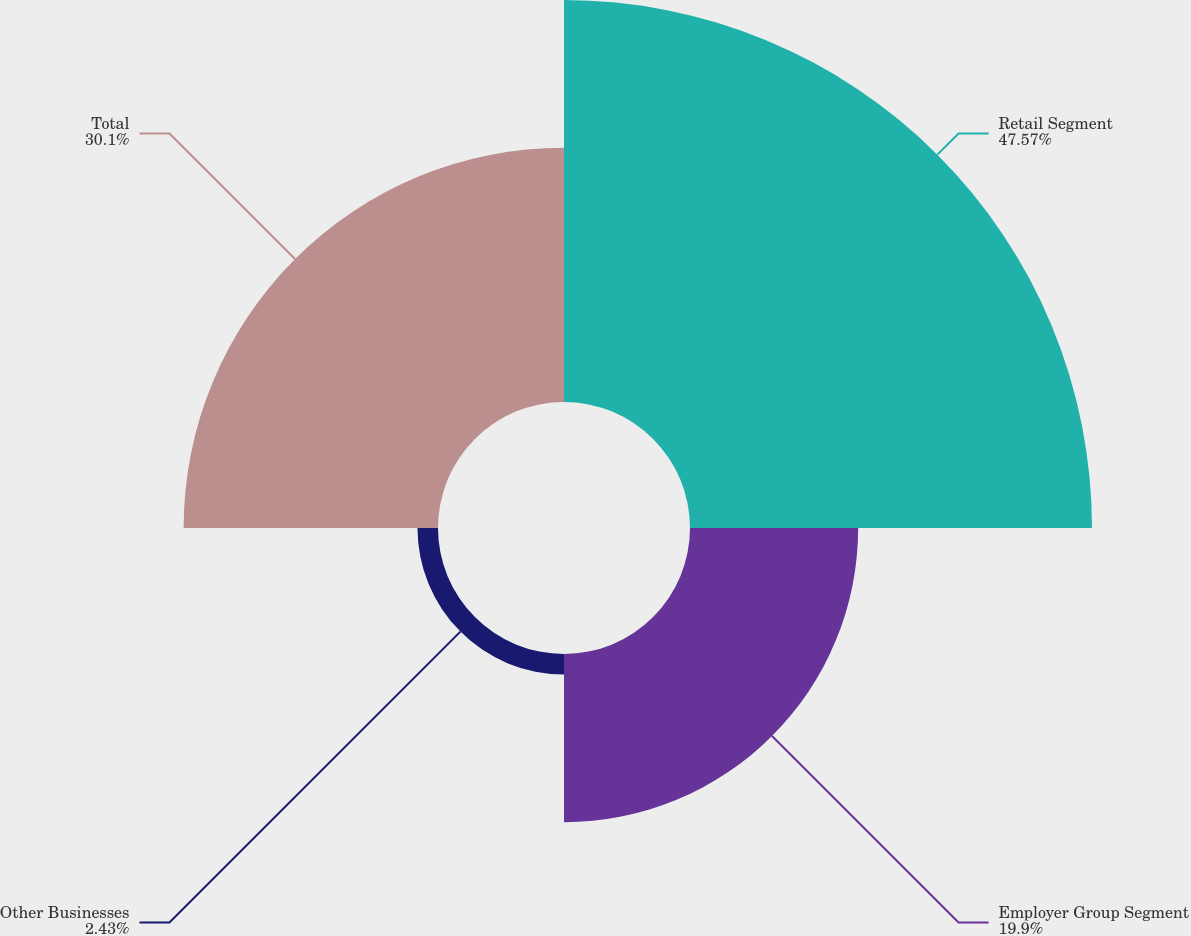Convert chart. <chart><loc_0><loc_0><loc_500><loc_500><pie_chart><fcel>Retail Segment<fcel>Employer Group Segment<fcel>Other Businesses<fcel>Total<nl><fcel>47.57%<fcel>19.9%<fcel>2.43%<fcel>30.1%<nl></chart> 